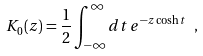<formula> <loc_0><loc_0><loc_500><loc_500>K _ { 0 } ( z ) = \frac { 1 } { 2 } \int _ { - \infty } ^ { \infty } d t \, e ^ { - z \cosh { t } } \ ,</formula> 